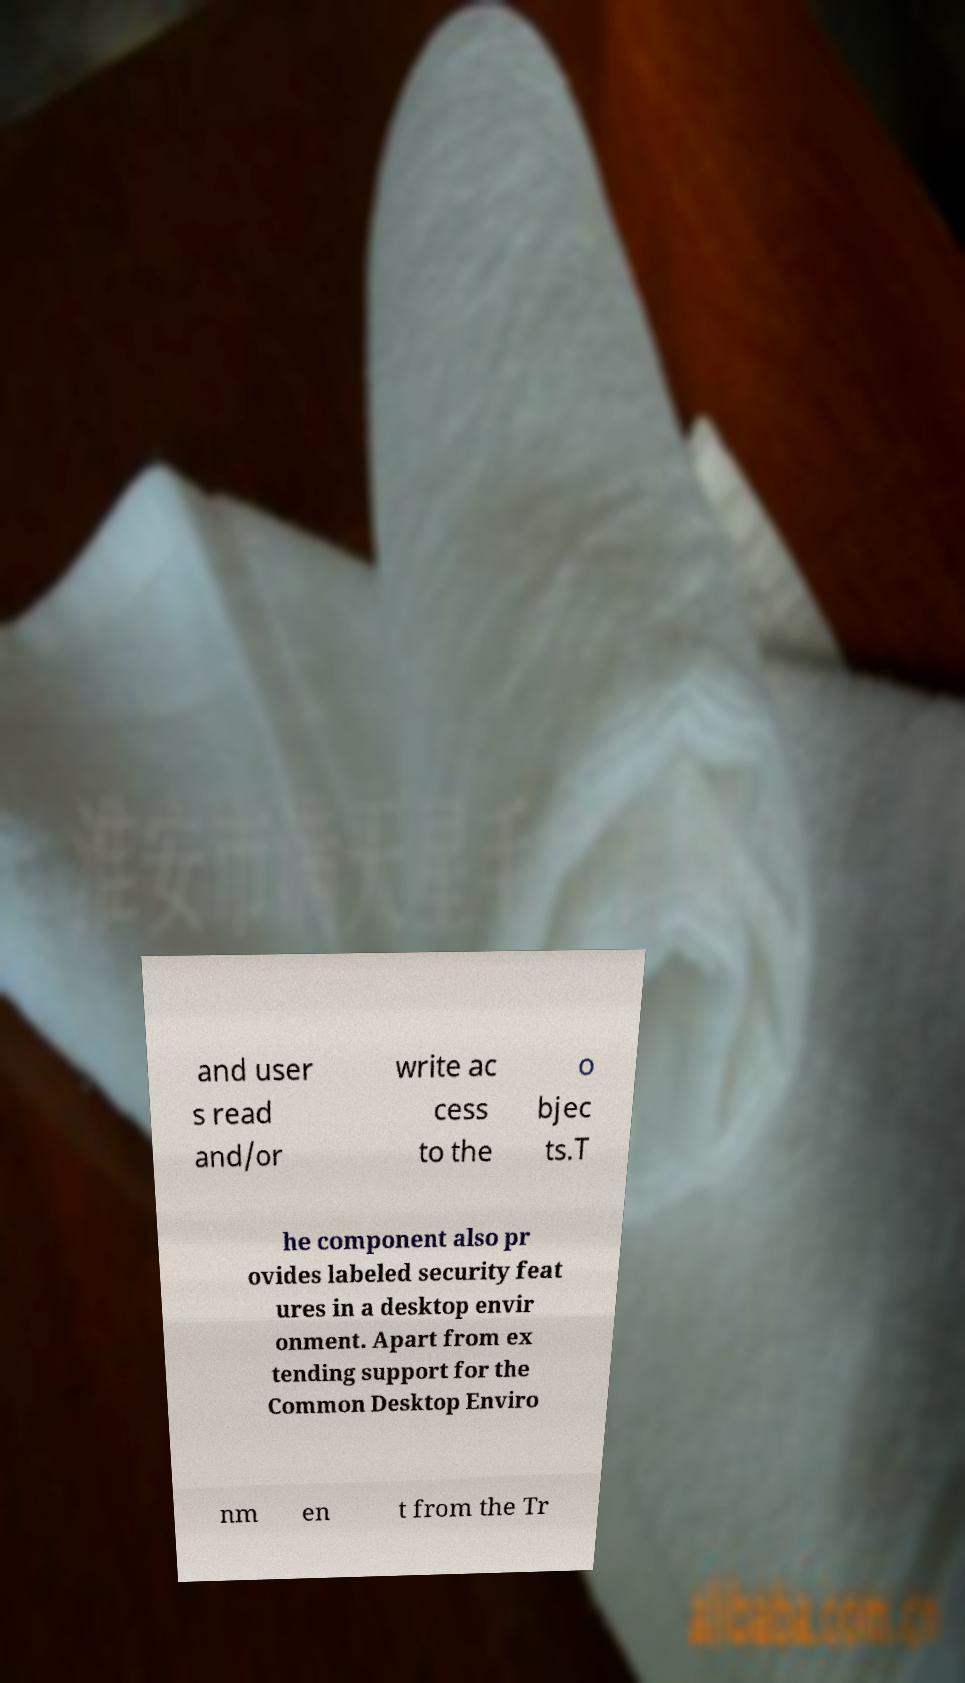Could you assist in decoding the text presented in this image and type it out clearly? and user s read and/or write ac cess to the o bjec ts.T he component also pr ovides labeled security feat ures in a desktop envir onment. Apart from ex tending support for the Common Desktop Enviro nm en t from the Tr 